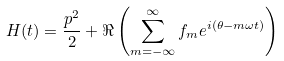<formula> <loc_0><loc_0><loc_500><loc_500>H ( t ) = \frac { p ^ { 2 } } { 2 } + \Re \left ( \sum _ { m = - \infty } ^ { \infty } f _ { m } e ^ { i ( \theta - m \omega t ) } \right )</formula> 